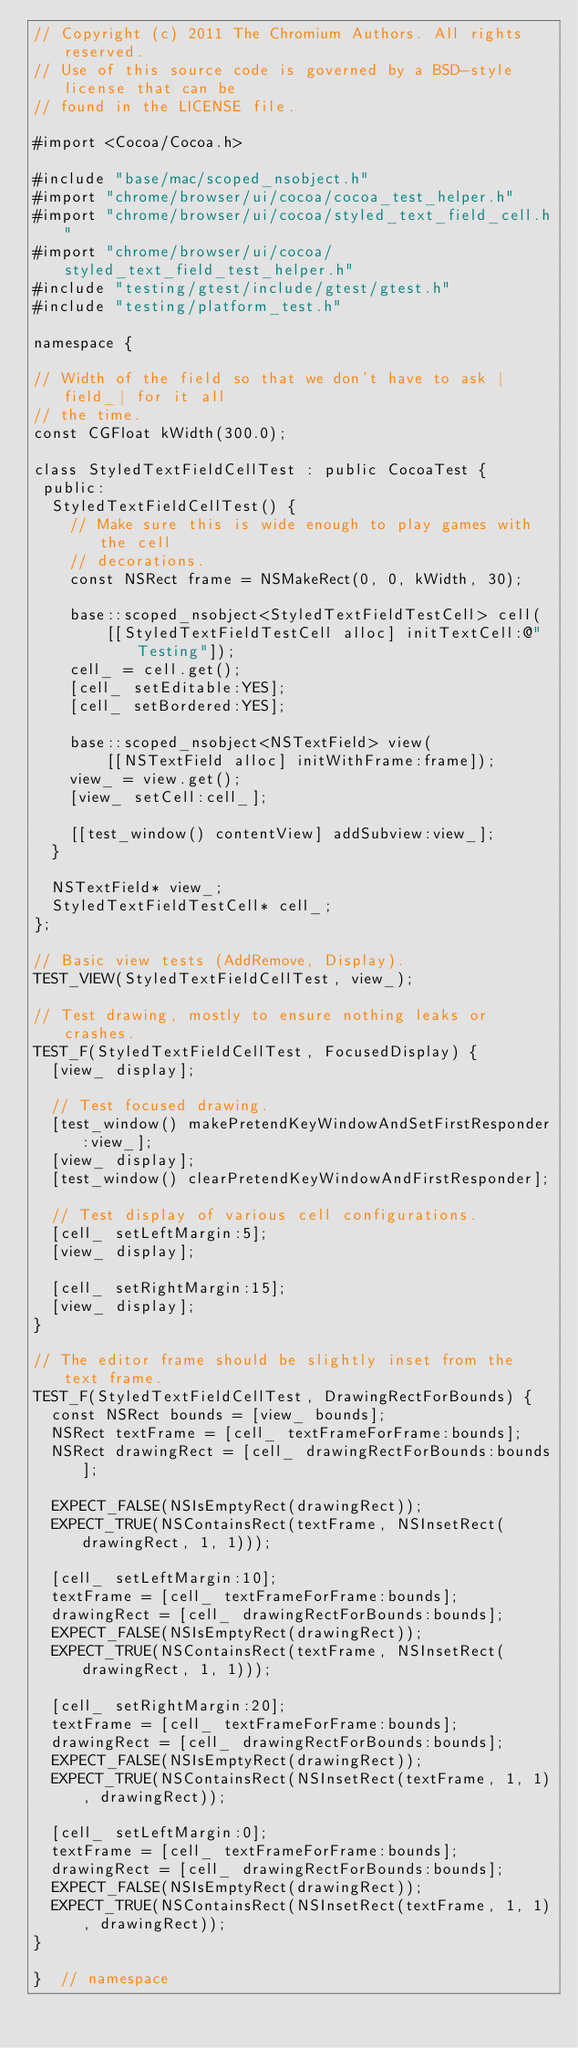<code> <loc_0><loc_0><loc_500><loc_500><_ObjectiveC_>// Copyright (c) 2011 The Chromium Authors. All rights reserved.
// Use of this source code is governed by a BSD-style license that can be
// found in the LICENSE file.

#import <Cocoa/Cocoa.h>

#include "base/mac/scoped_nsobject.h"
#import "chrome/browser/ui/cocoa/cocoa_test_helper.h"
#import "chrome/browser/ui/cocoa/styled_text_field_cell.h"
#import "chrome/browser/ui/cocoa/styled_text_field_test_helper.h"
#include "testing/gtest/include/gtest/gtest.h"
#include "testing/platform_test.h"

namespace {

// Width of the field so that we don't have to ask |field_| for it all
// the time.
const CGFloat kWidth(300.0);

class StyledTextFieldCellTest : public CocoaTest {
 public:
  StyledTextFieldCellTest() {
    // Make sure this is wide enough to play games with the cell
    // decorations.
    const NSRect frame = NSMakeRect(0, 0, kWidth, 30);

    base::scoped_nsobject<StyledTextFieldTestCell> cell(
        [[StyledTextFieldTestCell alloc] initTextCell:@"Testing"]);
    cell_ = cell.get();
    [cell_ setEditable:YES];
    [cell_ setBordered:YES];

    base::scoped_nsobject<NSTextField> view(
        [[NSTextField alloc] initWithFrame:frame]);
    view_ = view.get();
    [view_ setCell:cell_];

    [[test_window() contentView] addSubview:view_];
  }

  NSTextField* view_;
  StyledTextFieldTestCell* cell_;
};

// Basic view tests (AddRemove, Display).
TEST_VIEW(StyledTextFieldCellTest, view_);

// Test drawing, mostly to ensure nothing leaks or crashes.
TEST_F(StyledTextFieldCellTest, FocusedDisplay) {
  [view_ display];

  // Test focused drawing.
  [test_window() makePretendKeyWindowAndSetFirstResponder:view_];
  [view_ display];
  [test_window() clearPretendKeyWindowAndFirstResponder];

  // Test display of various cell configurations.
  [cell_ setLeftMargin:5];
  [view_ display];

  [cell_ setRightMargin:15];
  [view_ display];
}

// The editor frame should be slightly inset from the text frame.
TEST_F(StyledTextFieldCellTest, DrawingRectForBounds) {
  const NSRect bounds = [view_ bounds];
  NSRect textFrame = [cell_ textFrameForFrame:bounds];
  NSRect drawingRect = [cell_ drawingRectForBounds:bounds];

  EXPECT_FALSE(NSIsEmptyRect(drawingRect));
  EXPECT_TRUE(NSContainsRect(textFrame, NSInsetRect(drawingRect, 1, 1)));

  [cell_ setLeftMargin:10];
  textFrame = [cell_ textFrameForFrame:bounds];
  drawingRect = [cell_ drawingRectForBounds:bounds];
  EXPECT_FALSE(NSIsEmptyRect(drawingRect));
  EXPECT_TRUE(NSContainsRect(textFrame, NSInsetRect(drawingRect, 1, 1)));

  [cell_ setRightMargin:20];
  textFrame = [cell_ textFrameForFrame:bounds];
  drawingRect = [cell_ drawingRectForBounds:bounds];
  EXPECT_FALSE(NSIsEmptyRect(drawingRect));
  EXPECT_TRUE(NSContainsRect(NSInsetRect(textFrame, 1, 1), drawingRect));

  [cell_ setLeftMargin:0];
  textFrame = [cell_ textFrameForFrame:bounds];
  drawingRect = [cell_ drawingRectForBounds:bounds];
  EXPECT_FALSE(NSIsEmptyRect(drawingRect));
  EXPECT_TRUE(NSContainsRect(NSInsetRect(textFrame, 1, 1), drawingRect));
}

}  // namespace
</code> 